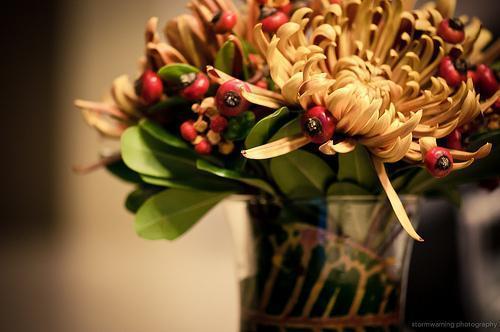How many different types of flowers are shown?
Give a very brief answer. 1. 